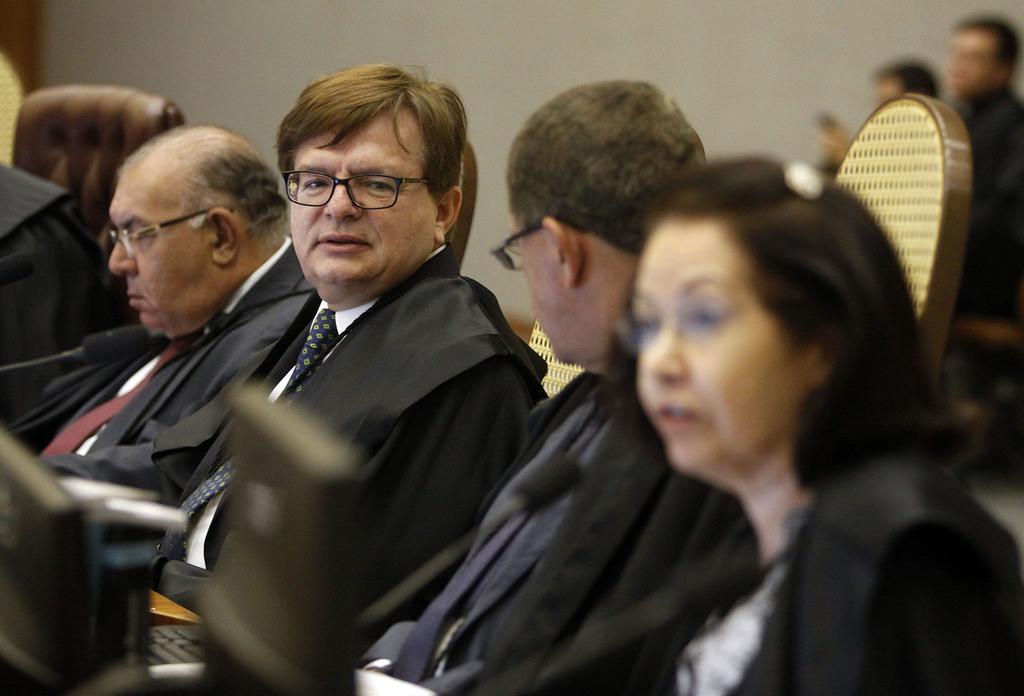How would you summarize this image in a sentence or two? This image is taken indoors. In the background there is a wall. In the middle of the image a few people are sitting on the chairs. At the bottom of the image there is a table with a few things on it. 